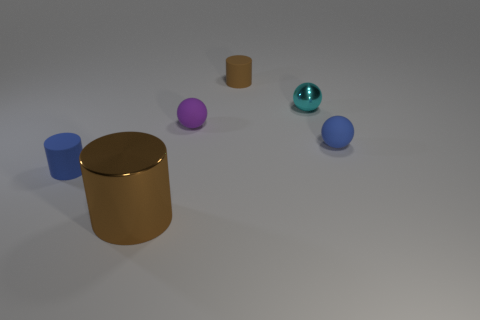If I were to add another object to this set, what would complement the existing arrangement? Adding a cube-shaped object could complement the existing geometric arrangement by introducing another fundamental shape. Selecting a green or orange color for the cube would maintain the colorful variety without repeating the existing color palette, and help to create a balanced composition in terms of both shape and color diversity. 